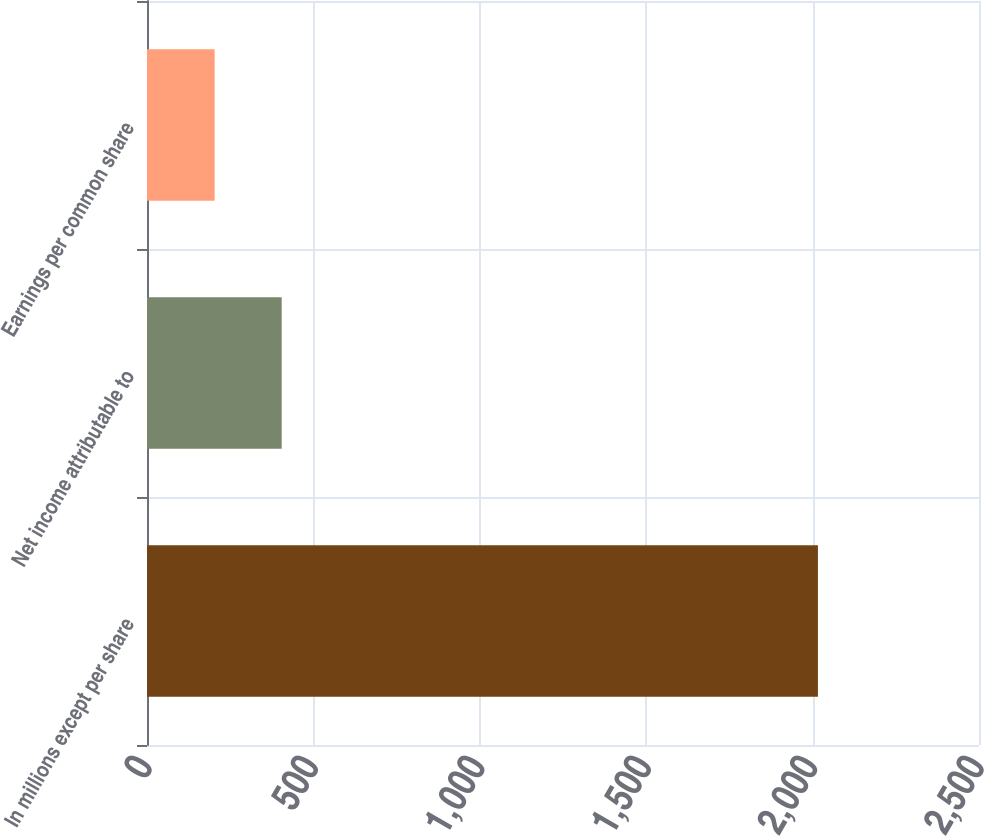Convert chart. <chart><loc_0><loc_0><loc_500><loc_500><bar_chart><fcel>In millions except per share<fcel>Net income attributable to<fcel>Earnings per common share<nl><fcel>2016<fcel>404.69<fcel>203.28<nl></chart> 